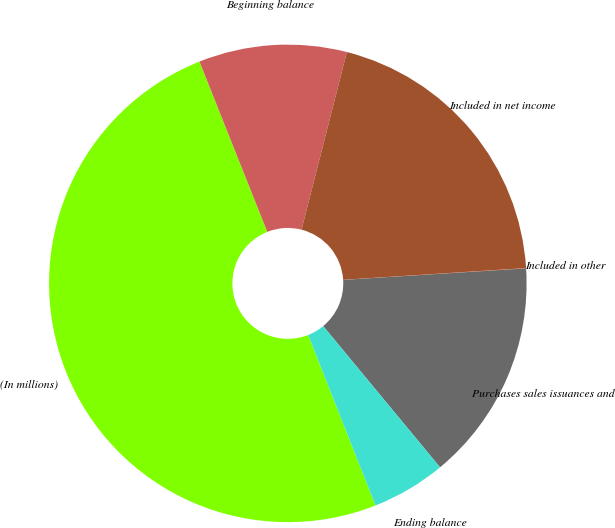Convert chart. <chart><loc_0><loc_0><loc_500><loc_500><pie_chart><fcel>(In millions)<fcel>Beginning balance<fcel>Included in net income<fcel>Included in other<fcel>Purchases sales issuances and<fcel>Ending balance<nl><fcel>49.95%<fcel>10.01%<fcel>20.0%<fcel>0.02%<fcel>15.0%<fcel>5.02%<nl></chart> 